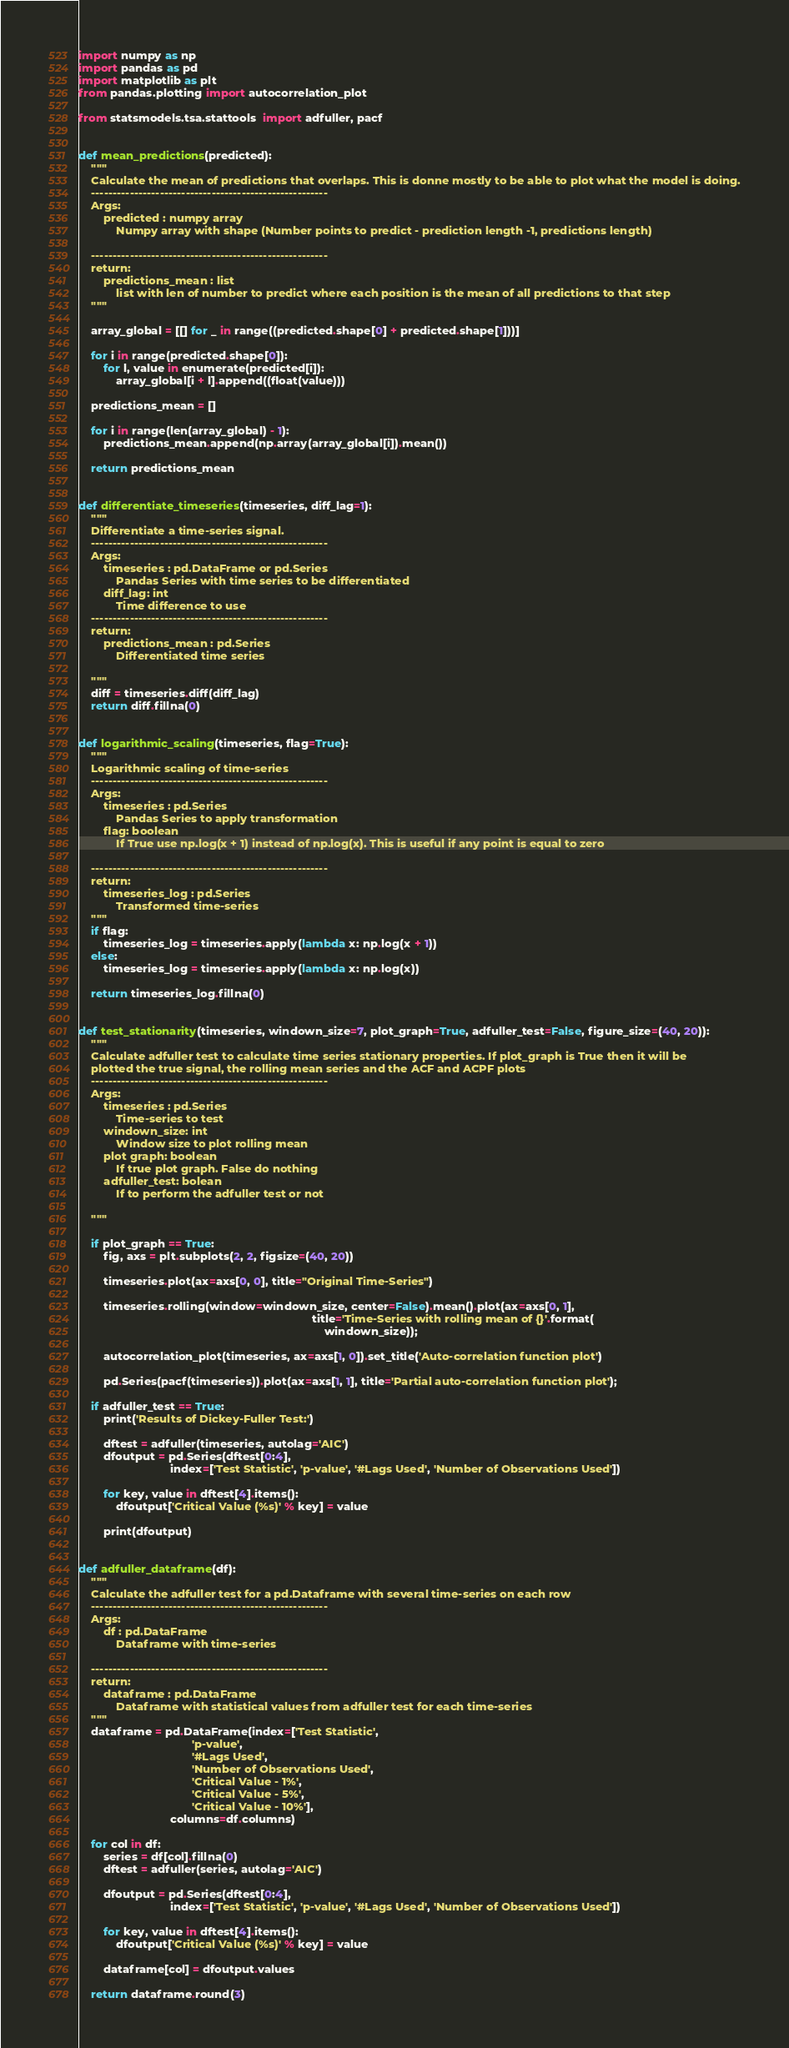<code> <loc_0><loc_0><loc_500><loc_500><_Python_>import numpy as np
import pandas as pd
import matplotlib as plt
from pandas.plotting import autocorrelation_plot

from statsmodels.tsa.stattools  import adfuller, pacf


def mean_predictions(predicted):
    """
    Calculate the mean of predictions that overlaps. This is donne mostly to be able to plot what the model is doing.
    -------------------------------------------------------
    Args:
        predicted : numpy array
            Numpy array with shape (Number points to predict - prediction length -1, predictions length)

    -------------------------------------------------------
    return:
        predictions_mean : list
            list with len of number to predict where each position is the mean of all predictions to that step
    """

    array_global = [[] for _ in range((predicted.shape[0] + predicted.shape[1]))]

    for i in range(predicted.shape[0]):
        for l, value in enumerate(predicted[i]):
            array_global[i + l].append((float(value)))

    predictions_mean = []

    for i in range(len(array_global) - 1):
        predictions_mean.append(np.array(array_global[i]).mean())

    return predictions_mean


def differentiate_timeseries(timeseries, diff_lag=1):
    """
    Differentiate a time-series signal.
    -------------------------------------------------------
    Args:
        timeseries : pd.DataFrame or pd.Series
            Pandas Series with time series to be differentiated
        diff_lag: int
            Time difference to use
    -------------------------------------------------------
    return:
        predictions_mean : pd.Series
            Differentiated time series

    """
    diff = timeseries.diff(diff_lag)
    return diff.fillna(0)


def logarithmic_scaling(timeseries, flag=True):
    """
    Logarithmic scaling of time-series
    -------------------------------------------------------
    Args:
        timeseries : pd.Series
            Pandas Series to apply transformation
        flag: boolean
            If True use np.log(x + 1) instead of np.log(x). This is useful if any point is equal to zero

    -------------------------------------------------------
    return:
        timeseries_log : pd.Series
            Transformed time-series
    """
    if flag:
        timeseries_log = timeseries.apply(lambda x: np.log(x + 1))
    else:
        timeseries_log = timeseries.apply(lambda x: np.log(x))

    return timeseries_log.fillna(0)


def test_stationarity(timeseries, windown_size=7, plot_graph=True, adfuller_test=False, figure_size=(40, 20)):
    """
    Calculate adfuller test to calculate time series stationary properties. If plot_graph is True then it will be
    plotted the true signal, the rolling mean series and the ACF and ACPF plots
    -------------------------------------------------------
    Args:
        timeseries : pd.Series
            Time-series to test
        windown_size: int
            Window size to plot rolling mean
        plot graph: boolean
            If true plot graph. False do nothing
        adfuller_test: bolean
            If to perform the adfuller test or not

    """

    if plot_graph == True:
        fig, axs = plt.subplots(2, 2, figsize=(40, 20))

        timeseries.plot(ax=axs[0, 0], title="Original Time-Series")

        timeseries.rolling(window=windown_size, center=False).mean().plot(ax=axs[0, 1],
                                                                          title='Time-Series with rolling mean of {}'.format(
                                                                              windown_size));

        autocorrelation_plot(timeseries, ax=axs[1, 0]).set_title('Auto-correlation function plot')

        pd.Series(pacf(timeseries)).plot(ax=axs[1, 1], title='Partial auto-correlation function plot');

    if adfuller_test == True:
        print('Results of Dickey-Fuller Test:')

        dftest = adfuller(timeseries, autolag='AIC')
        dfoutput = pd.Series(dftest[0:4],
                             index=['Test Statistic', 'p-value', '#Lags Used', 'Number of Observations Used'])

        for key, value in dftest[4].items():
            dfoutput['Critical Value (%s)' % key] = value

        print(dfoutput)


def adfuller_dataframe(df):
    """
    Calculate the adfuller test for a pd.Dataframe with several time-series on each row
    -------------------------------------------------------
    Args:
        df : pd.DataFrame
            Dataframe with time-series

    -------------------------------------------------------
    return:
        dataframe : pd.DataFrame
            Dataframe with statistical values from adfuller test for each time-series
    """
    dataframe = pd.DataFrame(index=['Test Statistic',
                                    'p-value',
                                    '#Lags Used',
                                    'Number of Observations Used',
                                    'Critical Value - 1%',
                                    'Critical Value - 5%',
                                    'Critical Value - 10%'],
                             columns=df.columns)

    for col in df:
        series = df[col].fillna(0)
        dftest = adfuller(series, autolag='AIC')

        dfoutput = pd.Series(dftest[0:4],
                             index=['Test Statistic', 'p-value', '#Lags Used', 'Number of Observations Used'])

        for key, value in dftest[4].items():
            dfoutput['Critical Value (%s)' % key] = value

        dataframe[col] = dfoutput.values

    return dataframe.round(3)
</code> 